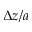<formula> <loc_0><loc_0><loc_500><loc_500>\Delta z / a</formula> 